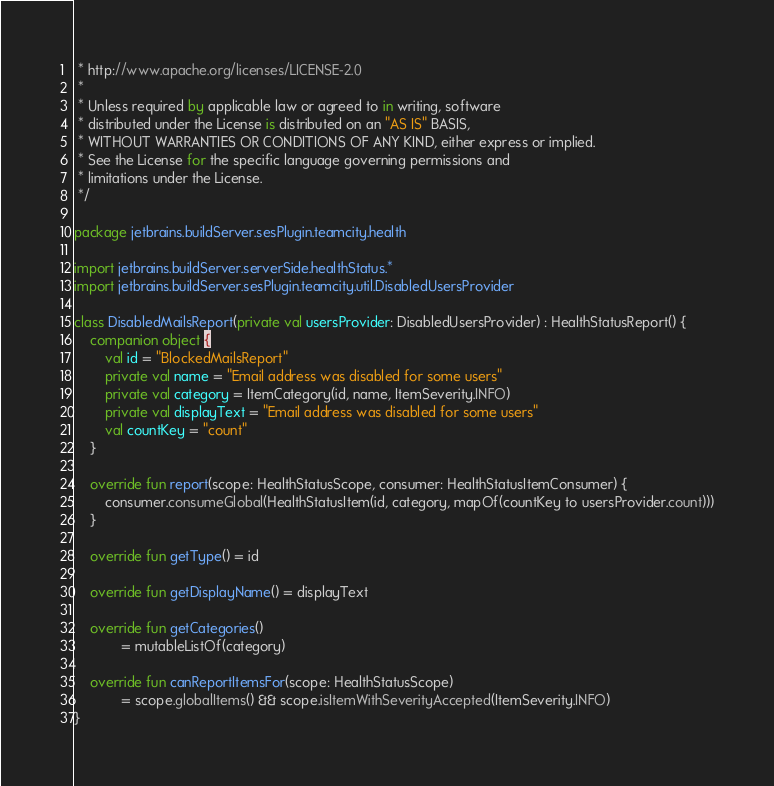Convert code to text. <code><loc_0><loc_0><loc_500><loc_500><_Kotlin_> * http://www.apache.org/licenses/LICENSE-2.0
 *
 * Unless required by applicable law or agreed to in writing, software
 * distributed under the License is distributed on an "AS IS" BASIS,
 * WITHOUT WARRANTIES OR CONDITIONS OF ANY KIND, either express or implied.
 * See the License for the specific language governing permissions and
 * limitations under the License.
 */

package jetbrains.buildServer.sesPlugin.teamcity.health

import jetbrains.buildServer.serverSide.healthStatus.*
import jetbrains.buildServer.sesPlugin.teamcity.util.DisabledUsersProvider

class DisabledMailsReport(private val usersProvider: DisabledUsersProvider) : HealthStatusReport() {
    companion object {
        val id = "BlockedMailsReport"
        private val name = "Email address was disabled for some users"
        private val category = ItemCategory(id, name, ItemSeverity.INFO)
        private val displayText = "Email address was disabled for some users"
        val countKey = "count"
    }

    override fun report(scope: HealthStatusScope, consumer: HealthStatusItemConsumer) {
        consumer.consumeGlobal(HealthStatusItem(id, category, mapOf(countKey to usersProvider.count)))
    }

    override fun getType() = id

    override fun getDisplayName() = displayText

    override fun getCategories()
            = mutableListOf(category)

    override fun canReportItemsFor(scope: HealthStatusScope)
            = scope.globalItems() && scope.isItemWithSeverityAccepted(ItemSeverity.INFO)
}</code> 